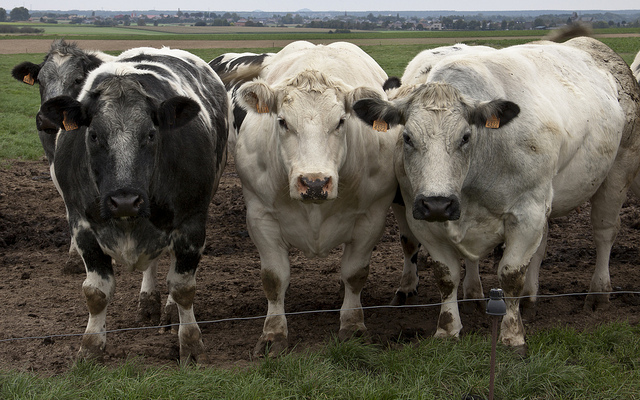Can you elaborate on the elements of the picture provided?
 On the left side, there's a black cow that occupies a substantial vertical portion of the image, followed by a mostly white cow with a few black patches standing beside it. These two cows are more towards the front of the image. Towards the right, three more cows are present. Two of them are primarily white, standing beside each other, occupying a significant horizontal stretch of the photo. One of them, situated further right, has its head lowered. Another cow, a bit behind these two and to their left, is peeking its head above the others, making it visible between them. 